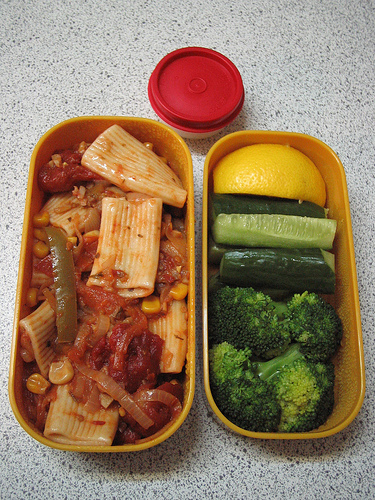<image>
Is the rigatoni in the dish? No. The rigatoni is not contained within the dish. These objects have a different spatial relationship. Is there a food behind the box? No. The food is not behind the box. From this viewpoint, the food appears to be positioned elsewhere in the scene. 